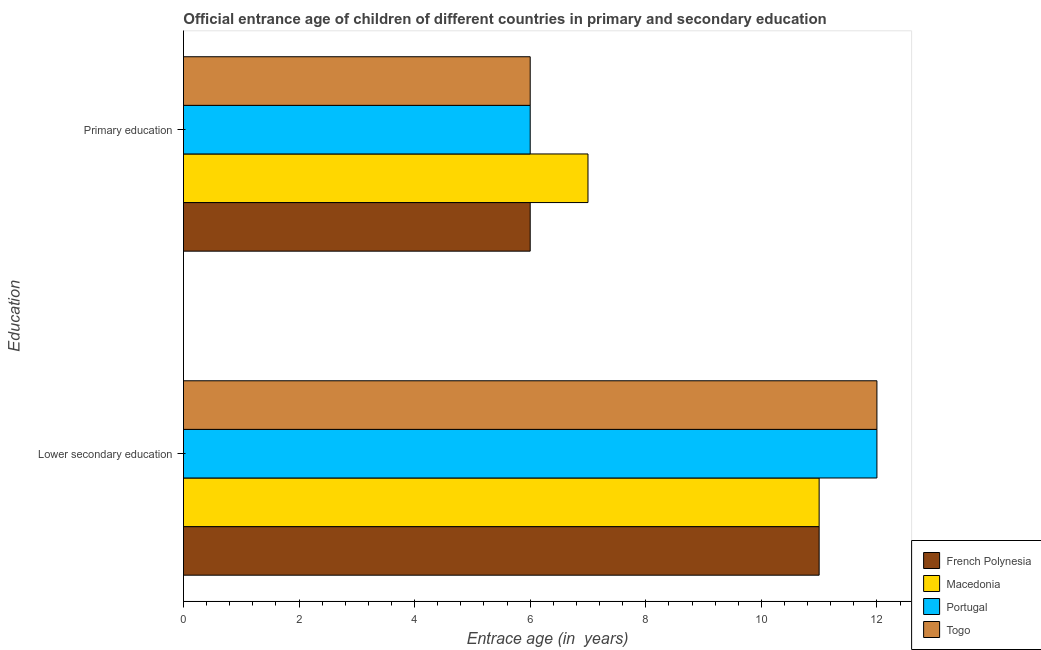How many groups of bars are there?
Provide a short and direct response. 2. Are the number of bars per tick equal to the number of legend labels?
Keep it short and to the point. Yes. What is the label of the 1st group of bars from the top?
Offer a terse response. Primary education. Across all countries, what is the maximum entrance age of children in lower secondary education?
Make the answer very short. 12. Across all countries, what is the minimum entrance age of children in lower secondary education?
Ensure brevity in your answer.  11. In which country was the entrance age of children in lower secondary education minimum?
Provide a short and direct response. French Polynesia. What is the total entrance age of children in lower secondary education in the graph?
Provide a succinct answer. 46. What is the difference between the entrance age of chiildren in primary education in French Polynesia and that in Macedonia?
Provide a short and direct response. -1. What is the difference between the entrance age of chiildren in primary education in Macedonia and the entrance age of children in lower secondary education in French Polynesia?
Ensure brevity in your answer.  -4. What is the average entrance age of children in lower secondary education per country?
Offer a very short reply. 11.5. What is the difference between the entrance age of chiildren in primary education and entrance age of children in lower secondary education in Macedonia?
Provide a succinct answer. -4. In how many countries, is the entrance age of children in lower secondary education greater than 2 years?
Offer a very short reply. 4. What is the ratio of the entrance age of children in lower secondary education in Togo to that in Macedonia?
Ensure brevity in your answer.  1.09. Is the entrance age of chiildren in primary education in French Polynesia less than that in Togo?
Keep it short and to the point. No. In how many countries, is the entrance age of children in lower secondary education greater than the average entrance age of children in lower secondary education taken over all countries?
Your answer should be compact. 2. What does the 1st bar from the top in Primary education represents?
Make the answer very short. Togo. What does the 1st bar from the bottom in Primary education represents?
Your response must be concise. French Polynesia. How many bars are there?
Your answer should be very brief. 8. Are all the bars in the graph horizontal?
Your response must be concise. Yes. Are the values on the major ticks of X-axis written in scientific E-notation?
Keep it short and to the point. No. Does the graph contain any zero values?
Your answer should be compact. No. Does the graph contain grids?
Ensure brevity in your answer.  No. How many legend labels are there?
Keep it short and to the point. 4. How are the legend labels stacked?
Your answer should be compact. Vertical. What is the title of the graph?
Your response must be concise. Official entrance age of children of different countries in primary and secondary education. What is the label or title of the X-axis?
Provide a succinct answer. Entrace age (in  years). What is the label or title of the Y-axis?
Offer a very short reply. Education. What is the Entrace age (in  years) of French Polynesia in Lower secondary education?
Offer a terse response. 11. What is the Entrace age (in  years) in Togo in Lower secondary education?
Offer a very short reply. 12. What is the Entrace age (in  years) in French Polynesia in Primary education?
Ensure brevity in your answer.  6. What is the Entrace age (in  years) in Macedonia in Primary education?
Keep it short and to the point. 7. What is the Entrace age (in  years) of Portugal in Primary education?
Offer a very short reply. 6. Across all Education, what is the minimum Entrace age (in  years) in French Polynesia?
Offer a very short reply. 6. Across all Education, what is the minimum Entrace age (in  years) in Togo?
Provide a succinct answer. 6. What is the total Entrace age (in  years) of French Polynesia in the graph?
Keep it short and to the point. 17. What is the total Entrace age (in  years) of Togo in the graph?
Offer a terse response. 18. What is the difference between the Entrace age (in  years) in Portugal in Lower secondary education and that in Primary education?
Ensure brevity in your answer.  6. What is the difference between the Entrace age (in  years) of Togo in Lower secondary education and that in Primary education?
Offer a very short reply. 6. What is the difference between the Entrace age (in  years) of French Polynesia in Lower secondary education and the Entrace age (in  years) of Togo in Primary education?
Give a very brief answer. 5. What is the difference between the Entrace age (in  years) of Macedonia in Lower secondary education and the Entrace age (in  years) of Portugal in Primary education?
Give a very brief answer. 5. What is the difference between the Entrace age (in  years) in Portugal in Lower secondary education and the Entrace age (in  years) in Togo in Primary education?
Ensure brevity in your answer.  6. What is the average Entrace age (in  years) of French Polynesia per Education?
Offer a very short reply. 8.5. What is the average Entrace age (in  years) in Macedonia per Education?
Your answer should be compact. 9. What is the average Entrace age (in  years) in Portugal per Education?
Give a very brief answer. 9. What is the difference between the Entrace age (in  years) in Macedonia and Entrace age (in  years) in Togo in Lower secondary education?
Give a very brief answer. -1. What is the difference between the Entrace age (in  years) of Portugal and Entrace age (in  years) of Togo in Lower secondary education?
Provide a succinct answer. 0. What is the difference between the Entrace age (in  years) of French Polynesia and Entrace age (in  years) of Macedonia in Primary education?
Your answer should be compact. -1. What is the difference between the Entrace age (in  years) of French Polynesia and Entrace age (in  years) of Portugal in Primary education?
Provide a succinct answer. 0. What is the difference between the Entrace age (in  years) of Macedonia and Entrace age (in  years) of Portugal in Primary education?
Make the answer very short. 1. What is the ratio of the Entrace age (in  years) of French Polynesia in Lower secondary education to that in Primary education?
Your answer should be compact. 1.83. What is the ratio of the Entrace age (in  years) of Macedonia in Lower secondary education to that in Primary education?
Offer a very short reply. 1.57. What is the ratio of the Entrace age (in  years) in Portugal in Lower secondary education to that in Primary education?
Your answer should be compact. 2. What is the ratio of the Entrace age (in  years) in Togo in Lower secondary education to that in Primary education?
Make the answer very short. 2. What is the difference between the highest and the second highest Entrace age (in  years) of Macedonia?
Your answer should be compact. 4. What is the difference between the highest and the second highest Entrace age (in  years) in Togo?
Make the answer very short. 6. What is the difference between the highest and the lowest Entrace age (in  years) in French Polynesia?
Your answer should be very brief. 5. What is the difference between the highest and the lowest Entrace age (in  years) in Portugal?
Your response must be concise. 6. What is the difference between the highest and the lowest Entrace age (in  years) of Togo?
Give a very brief answer. 6. 